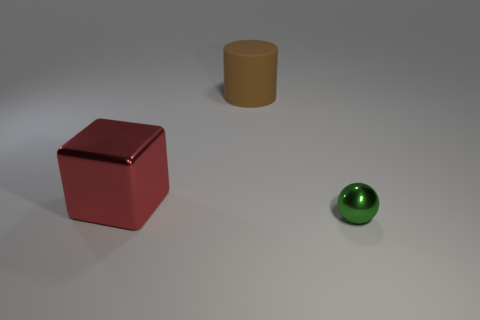Are there the same number of big things that are to the right of the brown matte thing and big purple matte cubes?
Your response must be concise. Yes. What number of other objects are there of the same color as the tiny thing?
Provide a short and direct response. 0. Is the number of red objects that are on the left side of the red metal cube less than the number of small brown metal spheres?
Your answer should be compact. No. Are there any red cubes of the same size as the rubber cylinder?
Your answer should be very brief. Yes. Do the metal ball and the metal thing on the left side of the brown matte cylinder have the same color?
Provide a succinct answer. No. What number of big things are behind the large thing that is behind the large cube?
Provide a succinct answer. 0. What is the color of the thing behind the metallic object behind the green object?
Offer a terse response. Brown. There is a object that is on the left side of the tiny green shiny sphere and in front of the rubber thing; what is it made of?
Make the answer very short. Metal. Is there a big red shiny thing that has the same shape as the tiny green shiny thing?
Your answer should be very brief. No. There is a metal object on the left side of the green metallic sphere; is it the same shape as the small thing?
Offer a very short reply. No. 